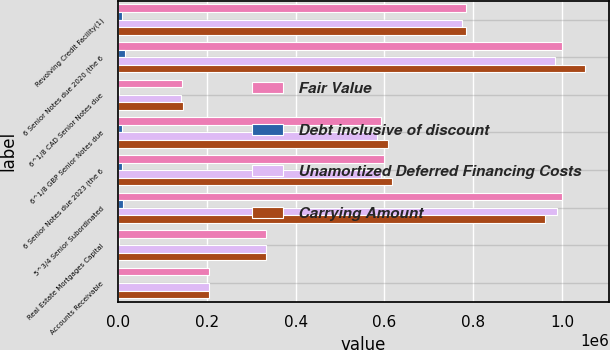<chart> <loc_0><loc_0><loc_500><loc_500><stacked_bar_chart><ecel><fcel>Revolving Credit Facility(1)<fcel>6 Senior Notes due 2020 (the 6<fcel>6^1/8 CAD Senior Notes due<fcel>6^1/8 GBP Senior Notes due<fcel>6 Senior Notes due 2023 (the 6<fcel>5^3/4 Senior Subordinated<fcel>Real Estate Mortgages Capital<fcel>Accounts Receivable<nl><fcel>Fair Value<fcel>784438<fcel>1e+06<fcel>144190<fcel>592140<fcel>600000<fcel>1e+06<fcel>333559<fcel>205900<nl><fcel>Debt inclusive of discount<fcel>9410<fcel>16124<fcel>1924<fcel>8757<fcel>8420<fcel>11902<fcel>1070<fcel>692<nl><fcel>Unamortized Deferred Financing Costs<fcel>775028<fcel>983876<fcel>142266<fcel>583383<fcel>591580<fcel>988098<fcel>332489<fcel>205208<nl><fcel>Carrying Amount<fcel>784438<fcel>1.0525e+06<fcel>147074<fcel>606944<fcel>618000<fcel>961200<fcel>333559<fcel>205900<nl></chart> 